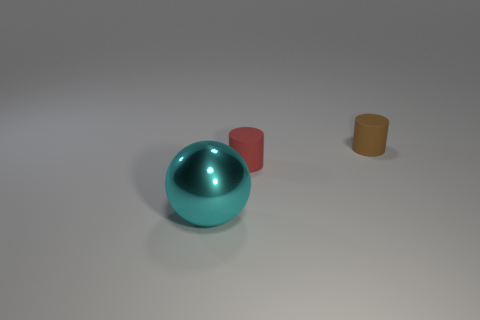Could you hypothesize a purpose for these objects? Without additional context, it's difficult to determine their exact purpose. The sphere could be a decorative item or part of a larger apparatus. The cylinders might serve as containers, stands, or components in some mechanical or artistic project. 